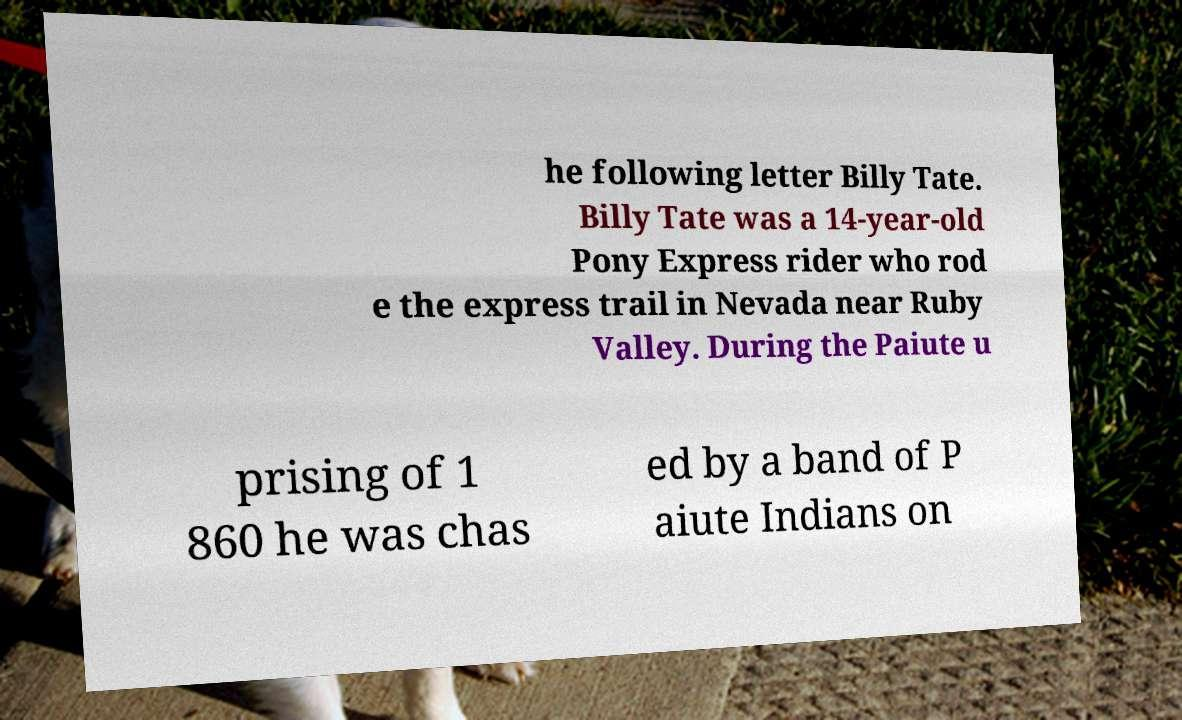Please identify and transcribe the text found in this image. he following letter Billy Tate. Billy Tate was a 14-year-old Pony Express rider who rod e the express trail in Nevada near Ruby Valley. During the Paiute u prising of 1 860 he was chas ed by a band of P aiute Indians on 